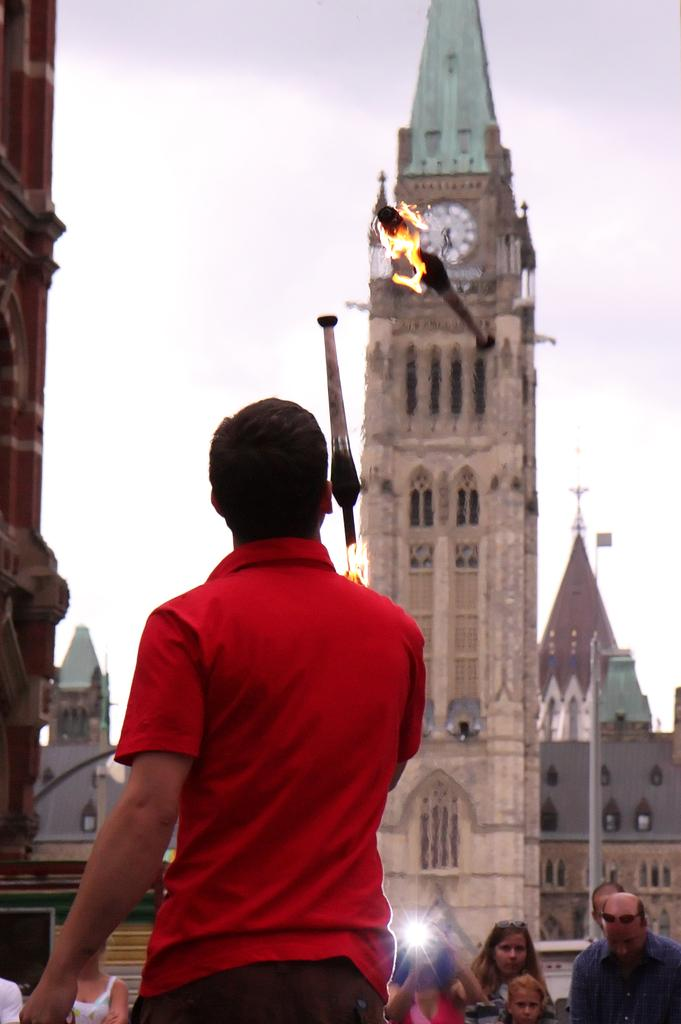What is the person in the foreground of the image doing? The person is standing and throwing fire sticks. Can you describe the people in the background of the image? There are people standing in the background. What structure is present in the image? There is a clock tower in the image. What feature does the clock tower have? The clock tower has a clock. What can be seen in the sky in the image? The sky is visible in the image. What type of lunch is being served in the image? There is no mention of lunch or any food in the image. 